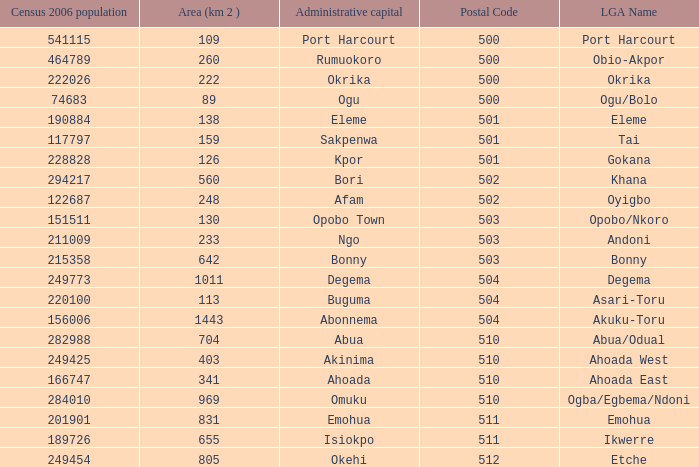What is the 2006 census population when the area is 159? 1.0. 